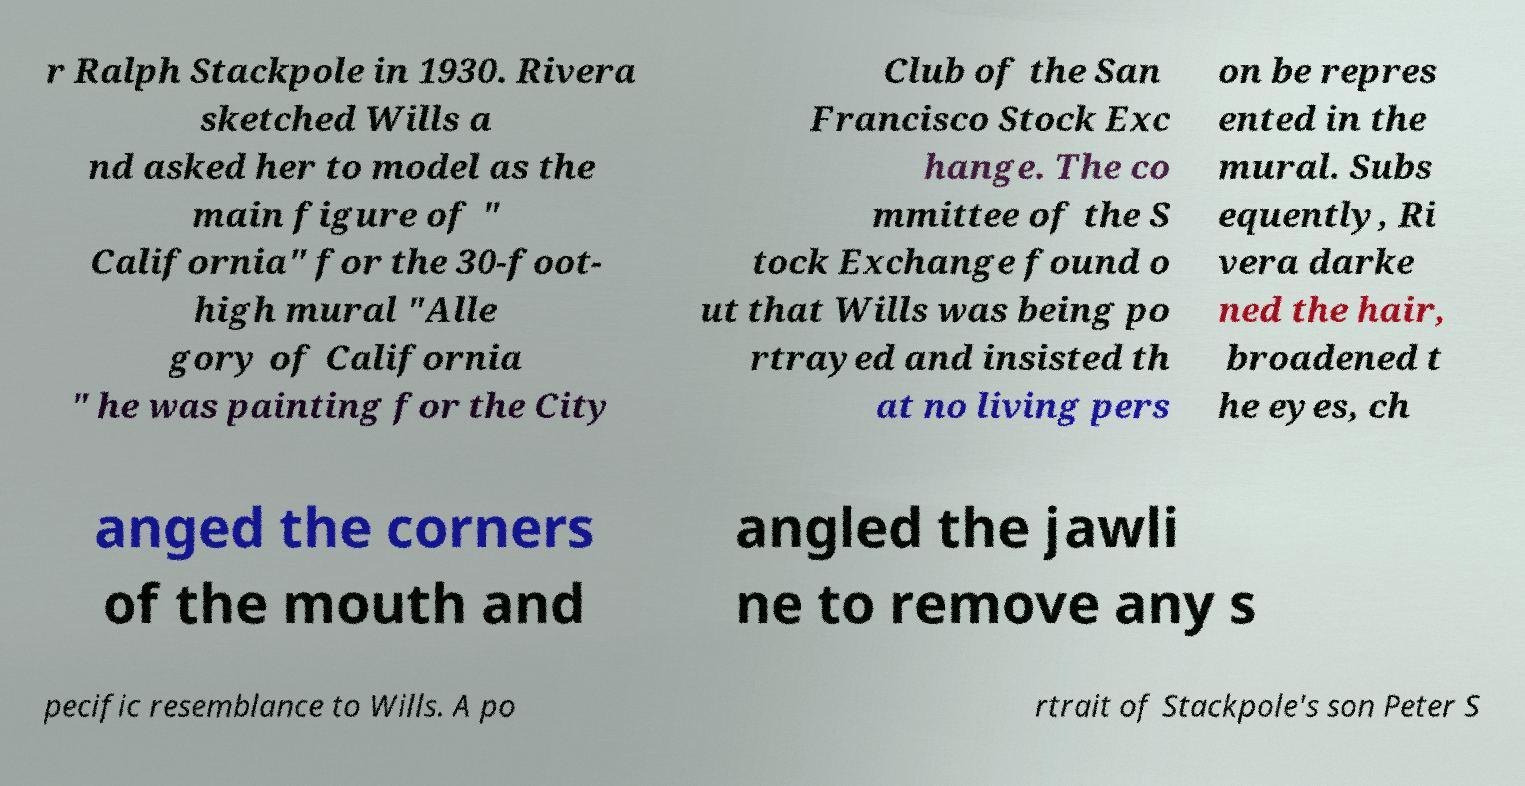There's text embedded in this image that I need extracted. Can you transcribe it verbatim? r Ralph Stackpole in 1930. Rivera sketched Wills a nd asked her to model as the main figure of " California" for the 30-foot- high mural "Alle gory of California " he was painting for the City Club of the San Francisco Stock Exc hange. The co mmittee of the S tock Exchange found o ut that Wills was being po rtrayed and insisted th at no living pers on be repres ented in the mural. Subs equently, Ri vera darke ned the hair, broadened t he eyes, ch anged the corners of the mouth and angled the jawli ne to remove any s pecific resemblance to Wills. A po rtrait of Stackpole's son Peter S 